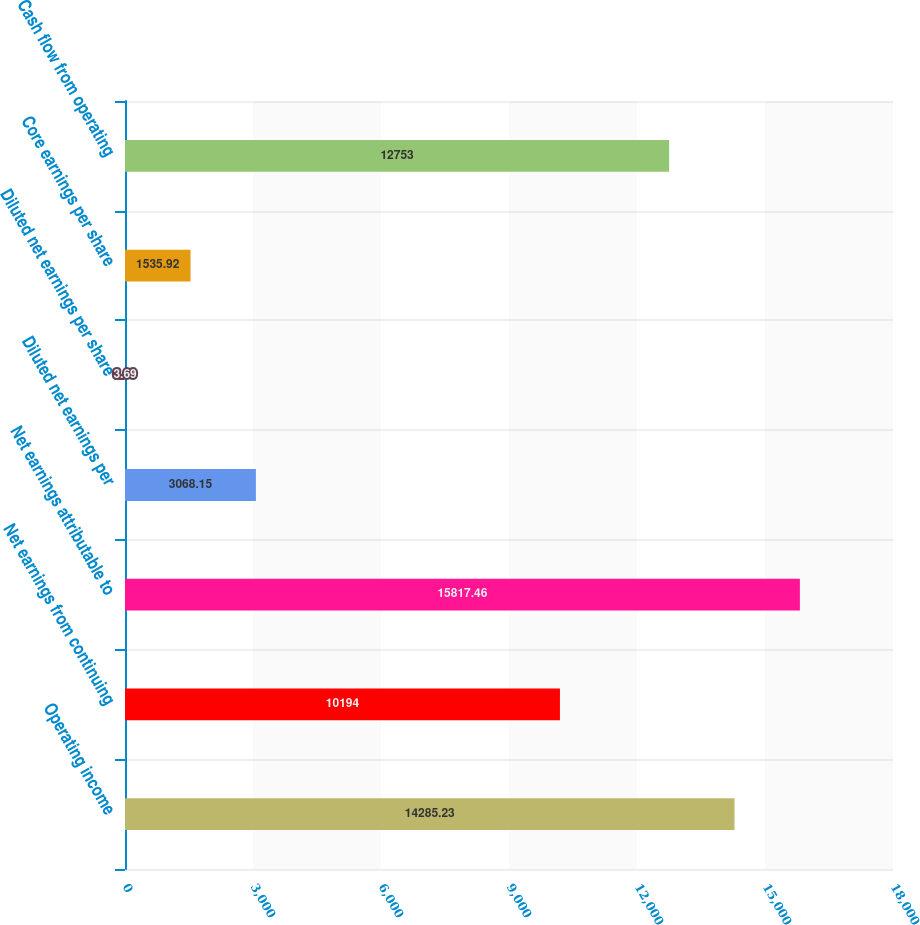<chart> <loc_0><loc_0><loc_500><loc_500><bar_chart><fcel>Operating income<fcel>Net earnings from continuing<fcel>Net earnings attributable to<fcel>Diluted net earnings per<fcel>Diluted net earnings per share<fcel>Core earnings per share<fcel>Cash flow from operating<nl><fcel>14285.2<fcel>10194<fcel>15817.5<fcel>3068.15<fcel>3.69<fcel>1535.92<fcel>12753<nl></chart> 